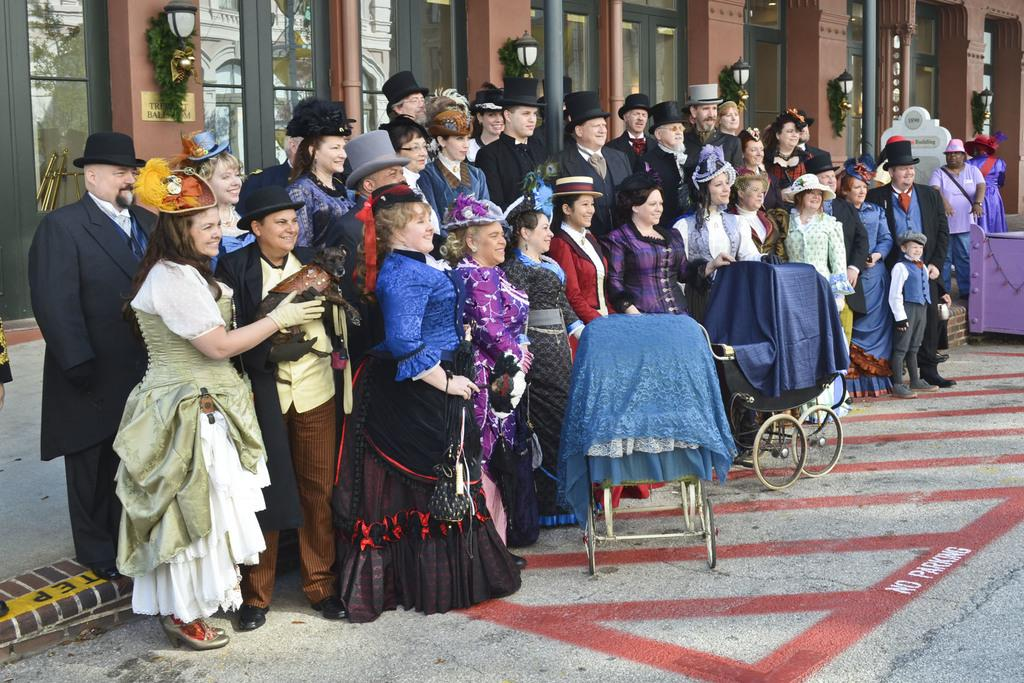What are the people in the image doing? There is a group of persons standing on the ground in the image. What can be seen in the background of the image? In the background of the image, there are plants, lights, poles, doors, and windows. What type of soup is being served in the image? There is no soup present in the image. Can you tell me how many seats are visible in the image? There is no mention of seats in the provided facts, so it cannot be determined from the image. 